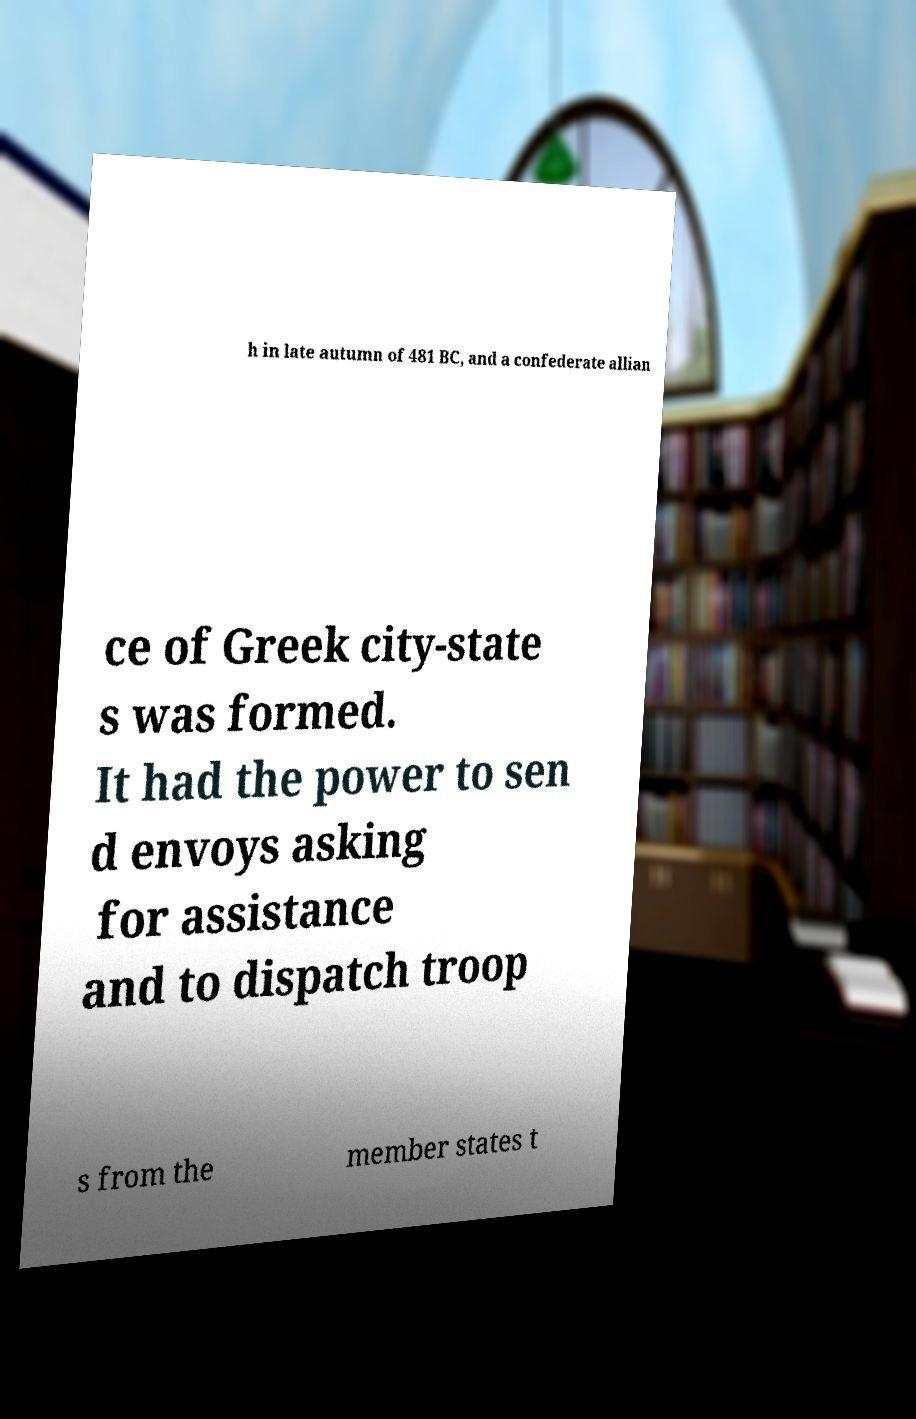Please identify and transcribe the text found in this image. h in late autumn of 481 BC, and a confederate allian ce of Greek city-state s was formed. It had the power to sen d envoys asking for assistance and to dispatch troop s from the member states t 